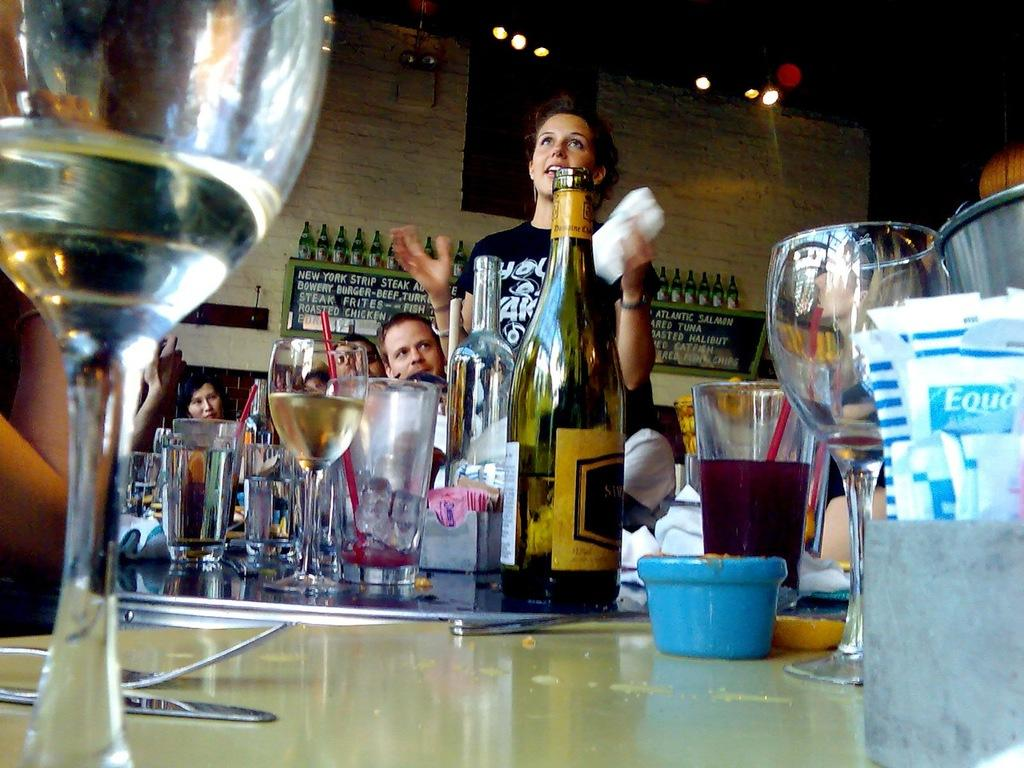What objects can be seen in the image related to serving or consuming beverages? There are glasses and a bottle of wine in the image. What other object is present in the image that is not related to beverages? There is a display board in the image. Are there any people visible in the image? Yes, there are people standing in the image. What type of pie is being served on the display board in the image? There is no pie present in the image; the display board is not related to food. 